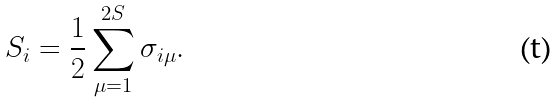Convert formula to latex. <formula><loc_0><loc_0><loc_500><loc_500>S _ { i } = \frac { 1 } { 2 } \sum _ { \mu = 1 } ^ { 2 S } \sigma _ { i \mu } .</formula> 